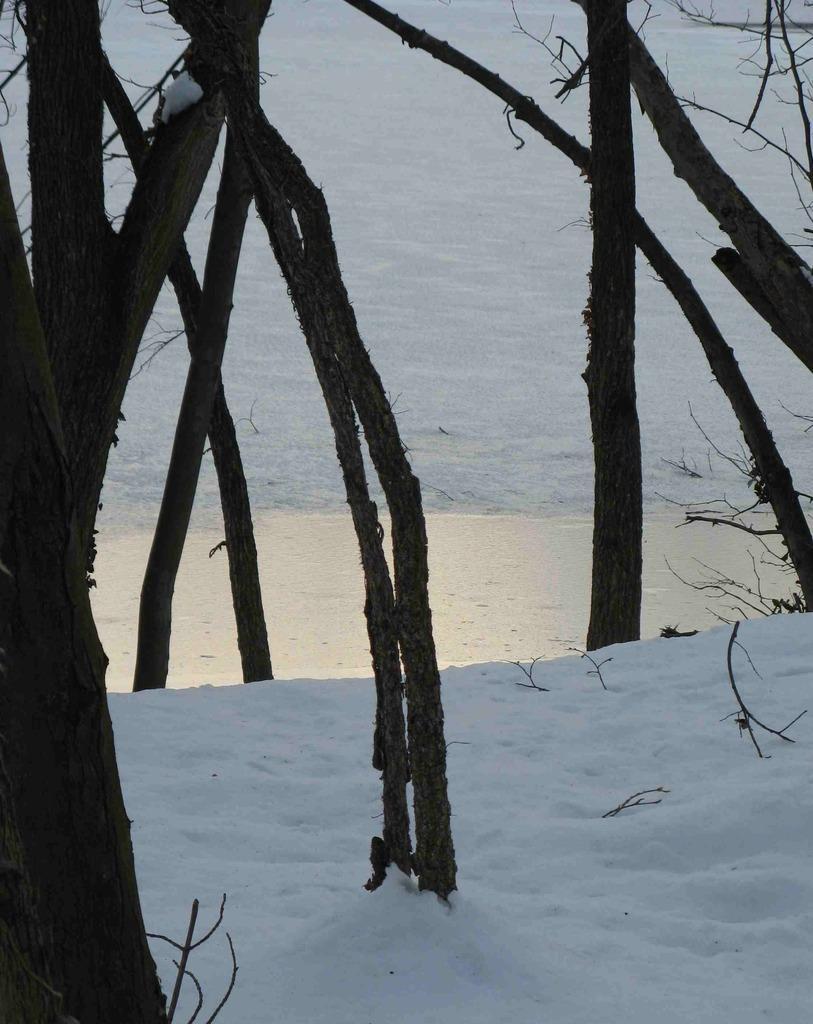How would you summarize this image in a sentence or two? In this image we can see the barks of the trees. At the bottom there is snow. 